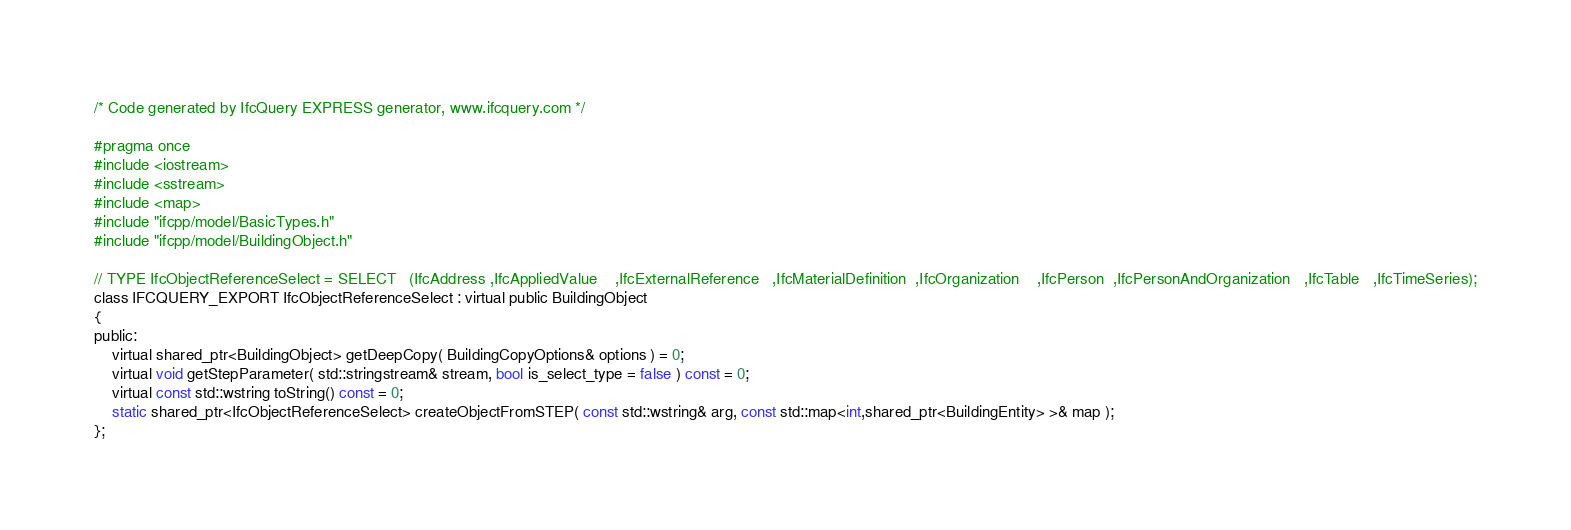<code> <loc_0><loc_0><loc_500><loc_500><_C_>/* Code generated by IfcQuery EXPRESS generator, www.ifcquery.com */

#pragma once
#include <iostream>
#include <sstream>
#include <map>
#include "ifcpp/model/BasicTypes.h"
#include "ifcpp/model/BuildingObject.h"

// TYPE IfcObjectReferenceSelect = SELECT	(IfcAddress	,IfcAppliedValue	,IfcExternalReference	,IfcMaterialDefinition	,IfcOrganization	,IfcPerson	,IfcPersonAndOrganization	,IfcTable	,IfcTimeSeries);
class IFCQUERY_EXPORT IfcObjectReferenceSelect : virtual public BuildingObject
{
public:
	virtual shared_ptr<BuildingObject> getDeepCopy( BuildingCopyOptions& options ) = 0;
	virtual void getStepParameter( std::stringstream& stream, bool is_select_type = false ) const = 0;
	virtual const std::wstring toString() const = 0;
	static shared_ptr<IfcObjectReferenceSelect> createObjectFromSTEP( const std::wstring& arg, const std::map<int,shared_ptr<BuildingEntity> >& map );
};

</code> 